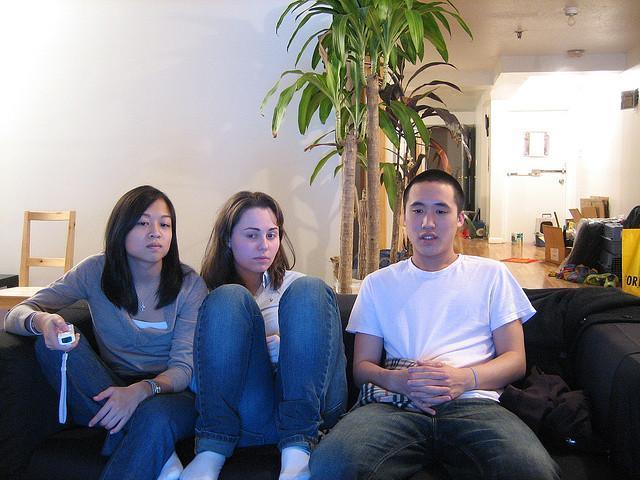How many people are visible?
Give a very brief answer. 3. 